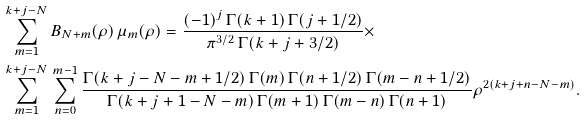Convert formula to latex. <formula><loc_0><loc_0><loc_500><loc_500>& \sum _ { m = 1 } ^ { k + j - N } B _ { N + m } ( \rho ) \, \mu _ { m } ( \rho ) = \frac { ( - 1 ) ^ { j } \, \Gamma ( k + 1 ) \, \Gamma ( j + 1 / 2 ) } { \pi ^ { 3 / 2 } \, \Gamma ( k + j + 3 / 2 ) } \times \\ & \sum _ { m = 1 } ^ { k + j - N } \, \sum _ { n = 0 } ^ { m - 1 } \frac { \Gamma ( k + j - N - m + 1 / 2 ) \, \Gamma ( m ) \, \Gamma ( n + 1 / 2 ) \, \Gamma ( m - n + 1 / 2 ) } { \Gamma ( k + j + 1 - N - m ) \, \Gamma ( m + 1 ) \, \Gamma ( m - n ) \, \Gamma ( n + 1 ) } \rho ^ { 2 ( k + j + n - N - m ) } .</formula> 